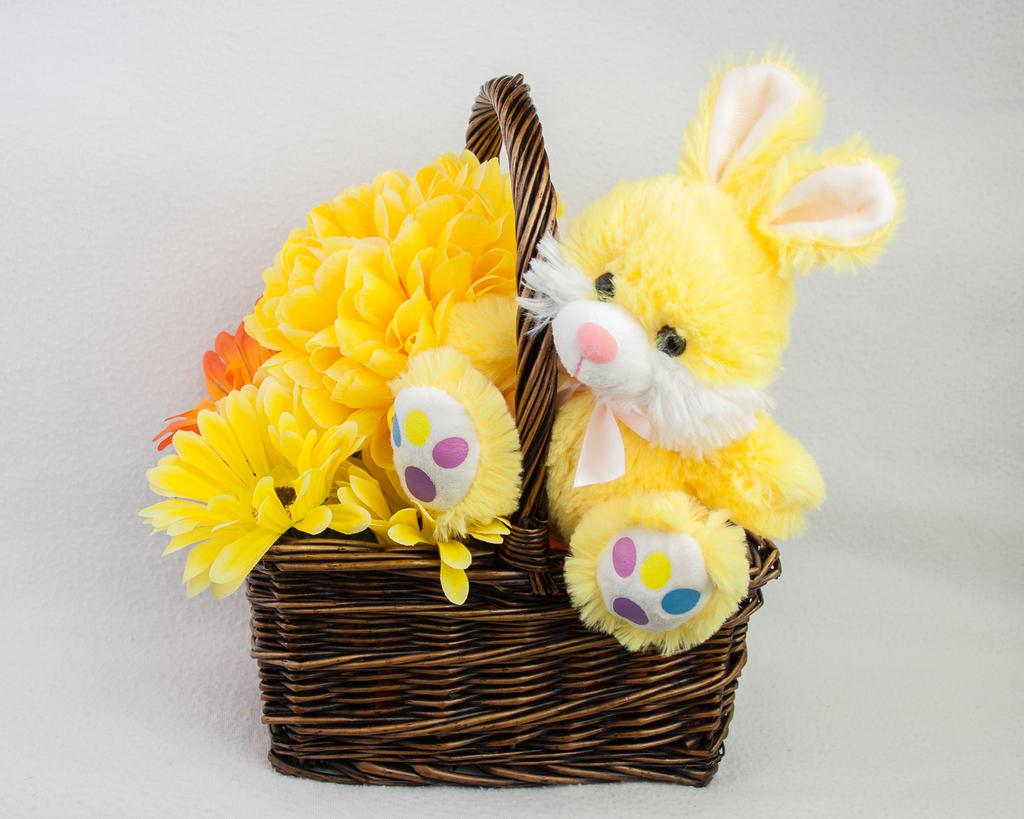What type of container is present in the image? There is a wooden basket in the image. What is inside the wooden basket? There are plastic flowers and a toy in the basket. What can be seen behind the basket in the image? There is a wall visible behind the basket. Is the writer of the image visible in the picture? There is no writer present in the image, as it is a still image and not a written work. 